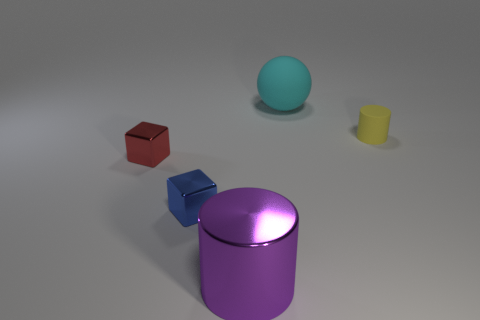Add 1 small yellow metal cubes. How many objects exist? 6 Subtract all cylinders. How many objects are left? 3 Subtract 0 gray spheres. How many objects are left? 5 Subtract all large objects. Subtract all yellow things. How many objects are left? 2 Add 1 purple things. How many purple things are left? 2 Add 1 large shiny objects. How many large shiny objects exist? 2 